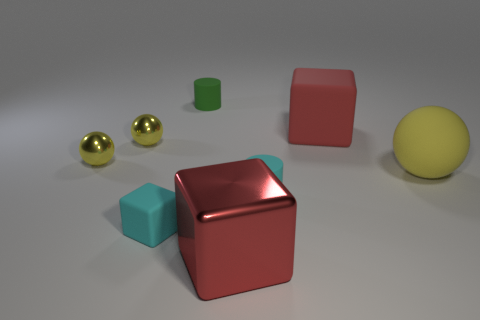Add 1 small yellow metallic balls. How many objects exist? 9 Subtract all balls. How many objects are left? 5 Subtract 0 yellow cylinders. How many objects are left? 8 Subtract all tiny yellow metal spheres. Subtract all cubes. How many objects are left? 3 Add 3 large spheres. How many large spheres are left? 4 Add 5 small matte cylinders. How many small matte cylinders exist? 7 